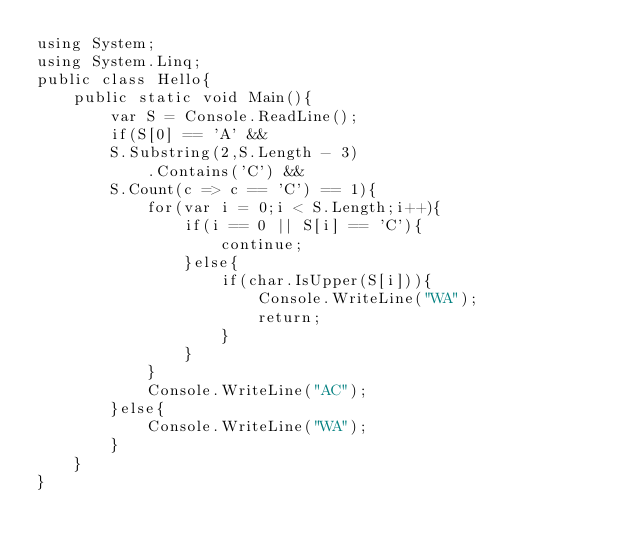Convert code to text. <code><loc_0><loc_0><loc_500><loc_500><_C#_>using System;
using System.Linq;
public class Hello{
    public static void Main(){
        var S = Console.ReadLine();
        if(S[0] == 'A' &&
        S.Substring(2,S.Length - 3)
            .Contains('C') &&
        S.Count(c => c == 'C') == 1){
            for(var i = 0;i < S.Length;i++){
                if(i == 0 || S[i] == 'C'){
                    continue;
                }else{
                    if(char.IsUpper(S[i])){
                        Console.WriteLine("WA");
                        return;
                    }
                }
            }
            Console.WriteLine("AC");
        }else{
            Console.WriteLine("WA");
        }
    }
}
</code> 